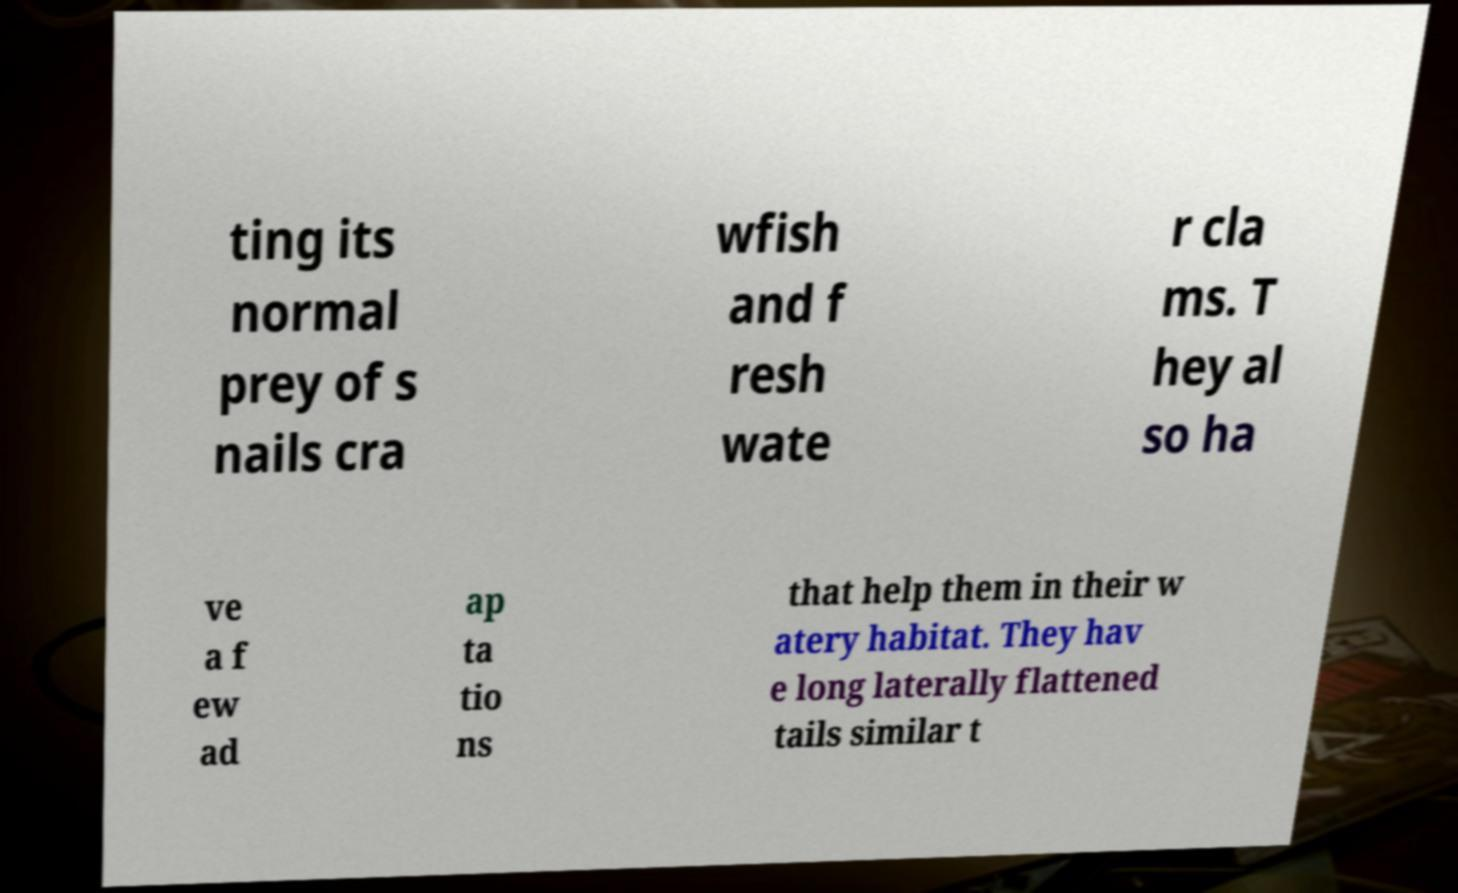What messages or text are displayed in this image? I need them in a readable, typed format. ting its normal prey of s nails cra wfish and f resh wate r cla ms. T hey al so ha ve a f ew ad ap ta tio ns that help them in their w atery habitat. They hav e long laterally flattened tails similar t 